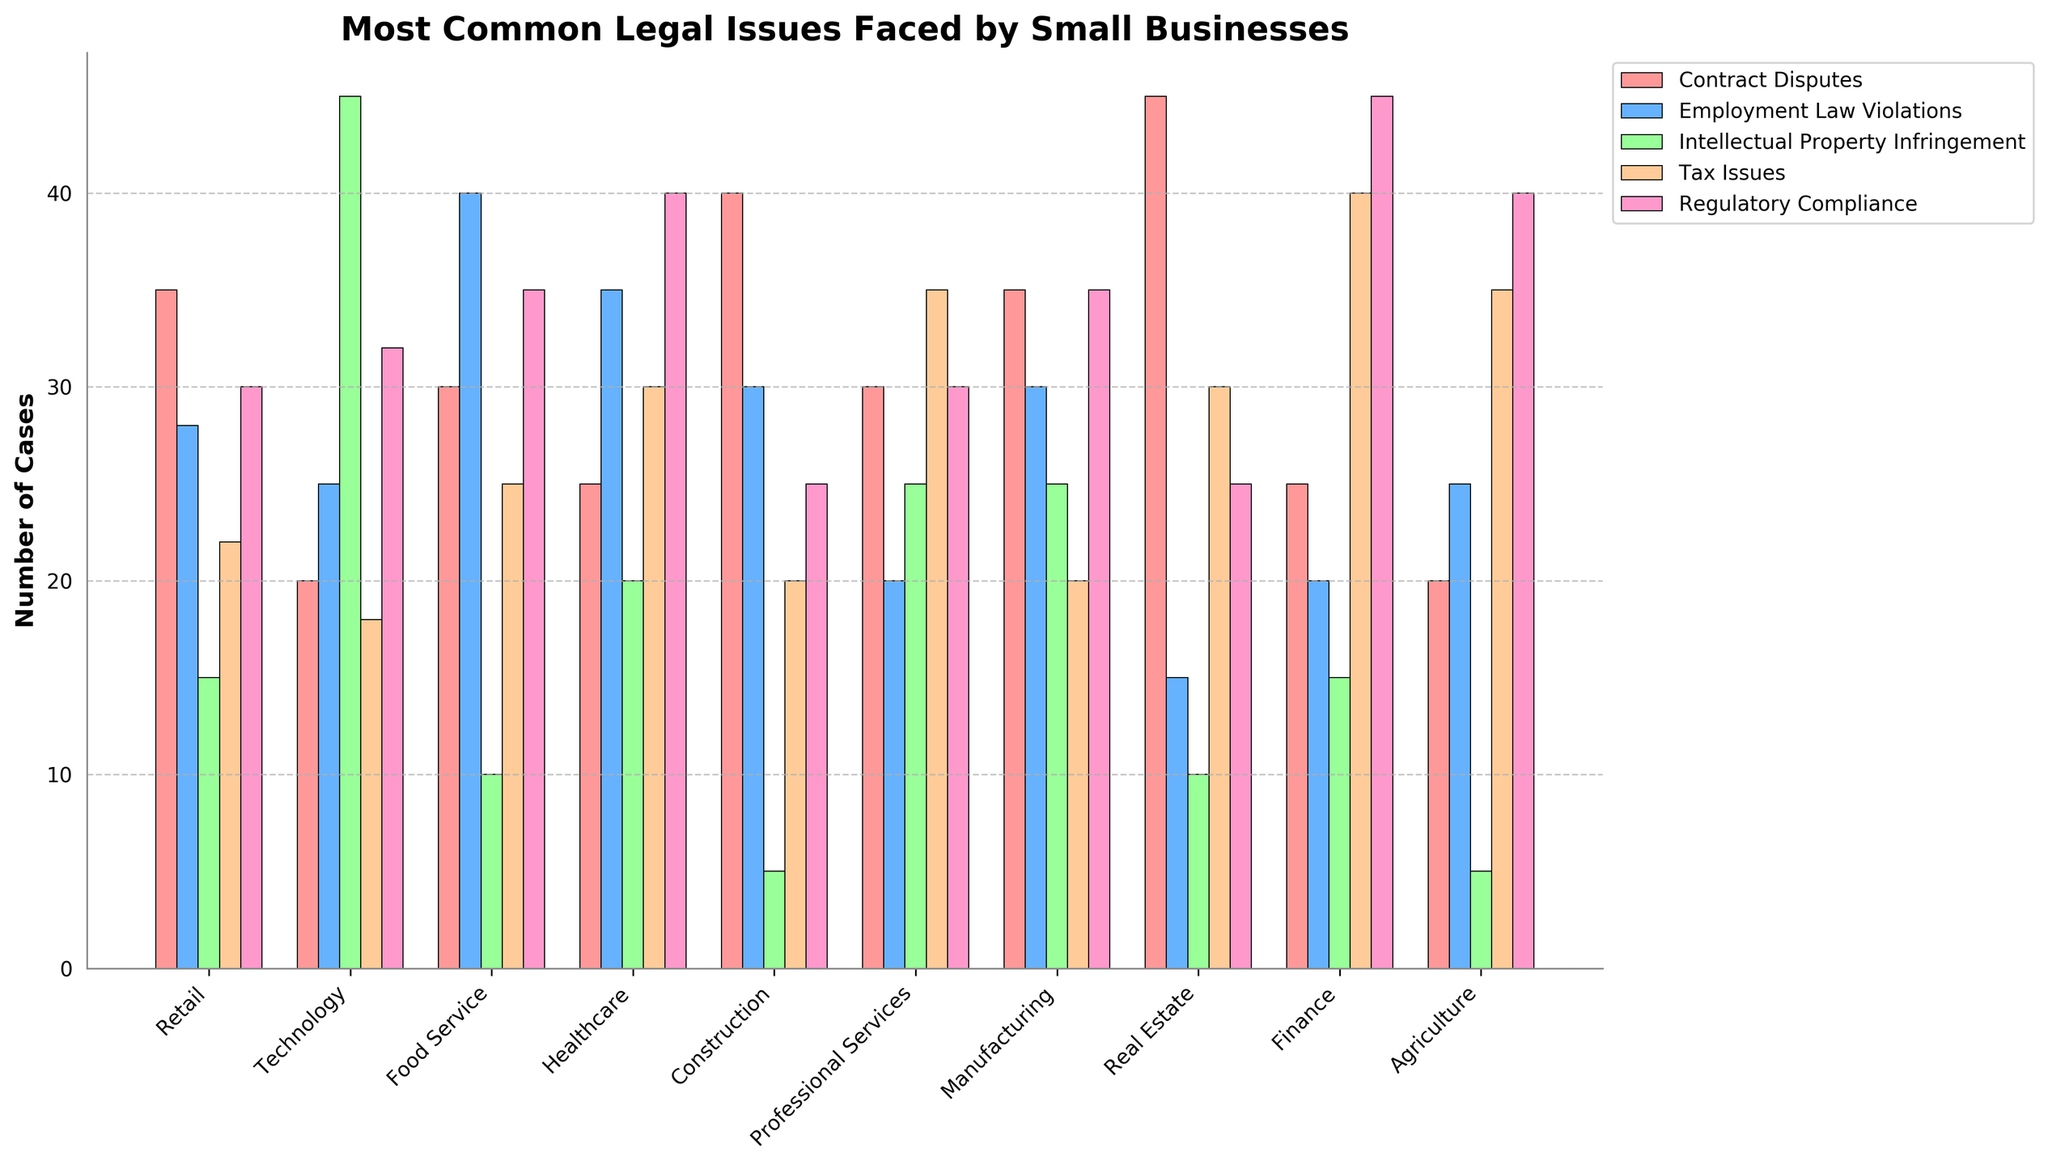Which industry has the highest number of Intellectual Property Infringement cases? By looking at the bar representing Intellectual Property Infringement cases, we can see that the Technology industry has the tallest bar in this category.
Answer: Technology Which industry has fewer than 20 Employment Law Violations cases? By analyzing the height of the Employment Law Violations bars, it is clear that Real Estate has fewer than 20 cases.
Answer: Real Estate What is the total number of Contract Disputes cases in the Retail and Construction industries? By summing the Contract Disputes cases from these industries: Retail (35) + Construction (40), the total is 75.
Answer: 75 Which two industries have the same number of Regulatory Compliance cases, and how many cases do they have? By comparing the heights of the Regulatory Compliance bars, we see that both Technology and Construction have bars of equal height, indicating they each have 32 Regulatory Compliance cases.
Answer: Technology and Construction, 32 cases What is the average number of Tax Issues cases across all industries? Sum the number of Tax Issues cases in all industries and divide by the number of industries: (22 + 18 + 25 + 30 + 20 + 35 + 20 + 30 + 40 + 35) = 275; then 275 / 10 = 27.5.
Answer: 27.5 Which industry has the most scattered (visually varied heights) legal issues, and what does this indicate? The Technology industry has a visually varied bar height across different issues (e.g., high for Intellectual Property Infringement, low for Contract Disputes). This indicates that legal challenges in this industry are diverse and not concentrated in one category.
Answer: Technology Which industry faces the highest number of cases in a single category, and what is that category? By identifying the tallest bar across all categories, we see that the Finance industry faces the highest number of cases in Regulatory Compliance (45).
Answer: Finance, Regulatory Compliance 